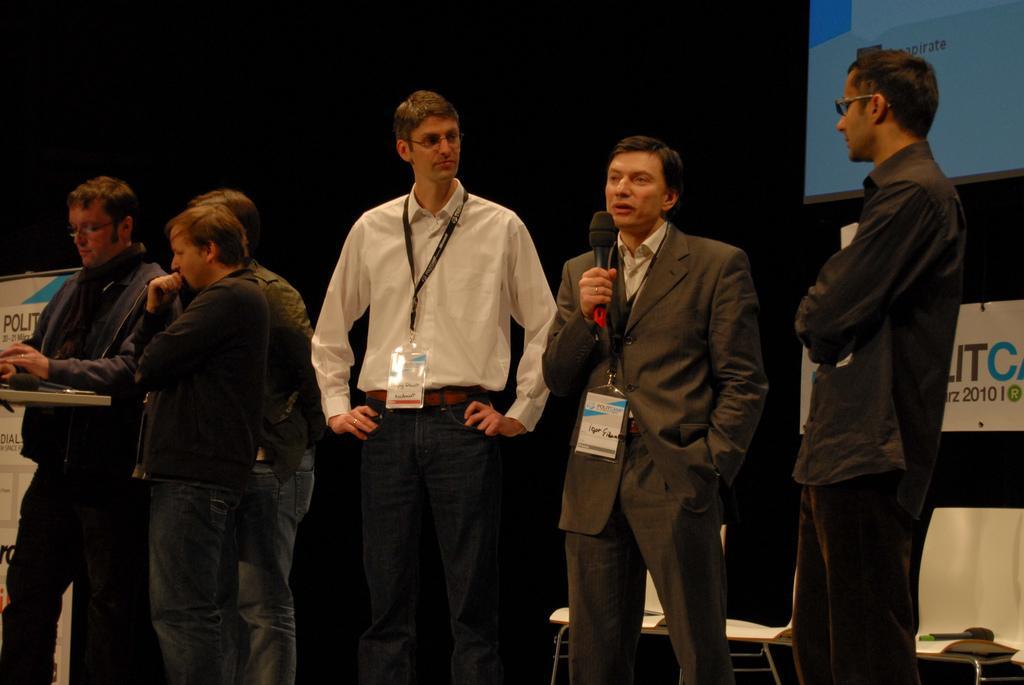How would you summarize this image in a sentence or two? In the foreground of this image, there are six men standing, two are wearing ID cards and a man is holding a mic. On the left, there is a table on which there is a mic. In the background, there are chairs, few boards and a screen in the dark. 